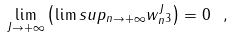Convert formula to latex. <formula><loc_0><loc_0><loc_500><loc_500>\lim _ { J \to + \infty } \left ( \lim s u p _ { n \to + \infty } \| w _ { n } ^ { J } \| _ { 3 } \right ) = 0 \ ,</formula> 